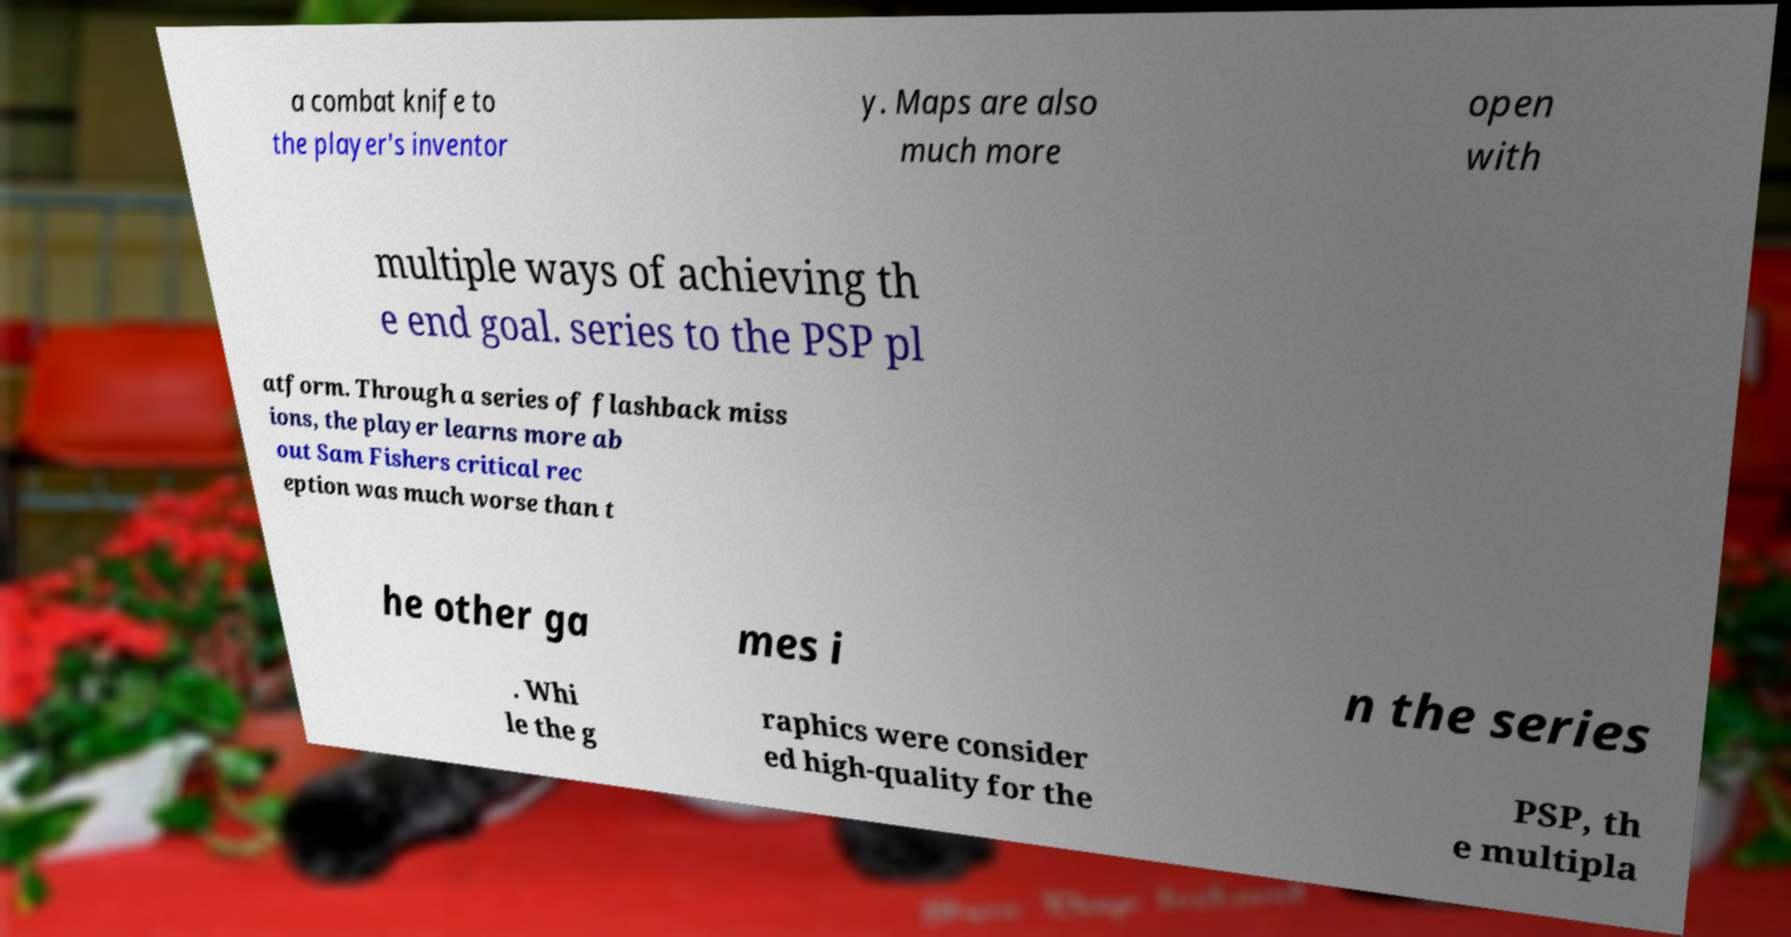Can you read and provide the text displayed in the image?This photo seems to have some interesting text. Can you extract and type it out for me? a combat knife to the player's inventor y. Maps are also much more open with multiple ways of achieving th e end goal. series to the PSP pl atform. Through a series of flashback miss ions, the player learns more ab out Sam Fishers critical rec eption was much worse than t he other ga mes i n the series . Whi le the g raphics were consider ed high-quality for the PSP, th e multipla 